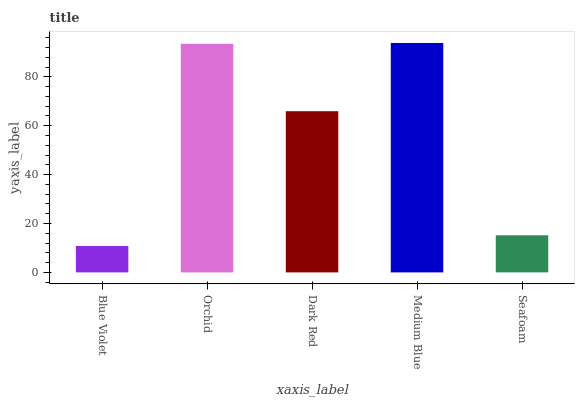Is Blue Violet the minimum?
Answer yes or no. Yes. Is Medium Blue the maximum?
Answer yes or no. Yes. Is Orchid the minimum?
Answer yes or no. No. Is Orchid the maximum?
Answer yes or no. No. Is Orchid greater than Blue Violet?
Answer yes or no. Yes. Is Blue Violet less than Orchid?
Answer yes or no. Yes. Is Blue Violet greater than Orchid?
Answer yes or no. No. Is Orchid less than Blue Violet?
Answer yes or no. No. Is Dark Red the high median?
Answer yes or no. Yes. Is Dark Red the low median?
Answer yes or no. Yes. Is Seafoam the high median?
Answer yes or no. No. Is Medium Blue the low median?
Answer yes or no. No. 